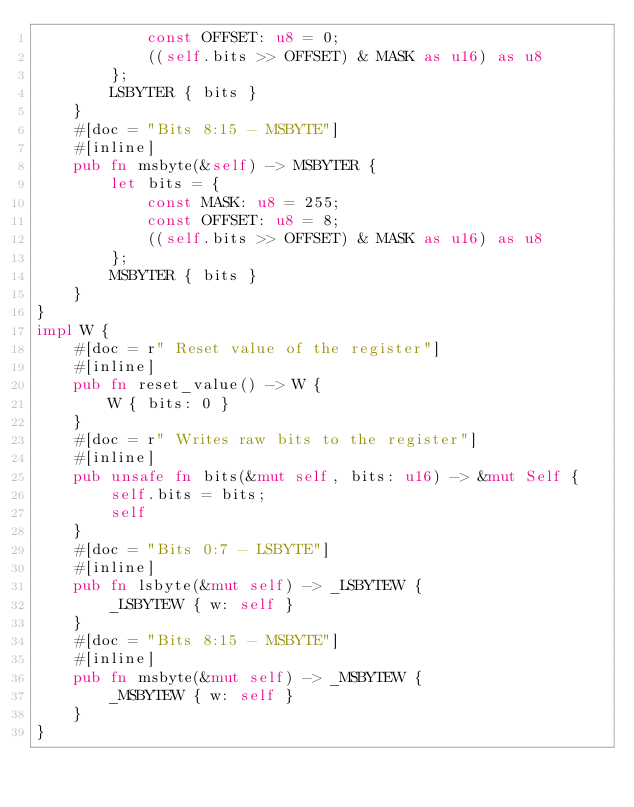<code> <loc_0><loc_0><loc_500><loc_500><_Rust_>            const OFFSET: u8 = 0;
            ((self.bits >> OFFSET) & MASK as u16) as u8
        };
        LSBYTER { bits }
    }
    #[doc = "Bits 8:15 - MSBYTE"]
    #[inline]
    pub fn msbyte(&self) -> MSBYTER {
        let bits = {
            const MASK: u8 = 255;
            const OFFSET: u8 = 8;
            ((self.bits >> OFFSET) & MASK as u16) as u8
        };
        MSBYTER { bits }
    }
}
impl W {
    #[doc = r" Reset value of the register"]
    #[inline]
    pub fn reset_value() -> W {
        W { bits: 0 }
    }
    #[doc = r" Writes raw bits to the register"]
    #[inline]
    pub unsafe fn bits(&mut self, bits: u16) -> &mut Self {
        self.bits = bits;
        self
    }
    #[doc = "Bits 0:7 - LSBYTE"]
    #[inline]
    pub fn lsbyte(&mut self) -> _LSBYTEW {
        _LSBYTEW { w: self }
    }
    #[doc = "Bits 8:15 - MSBYTE"]
    #[inline]
    pub fn msbyte(&mut self) -> _MSBYTEW {
        _MSBYTEW { w: self }
    }
}
</code> 